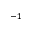Convert formula to latex. <formula><loc_0><loc_0><loc_500><loc_500>^ { - 1 }</formula> 